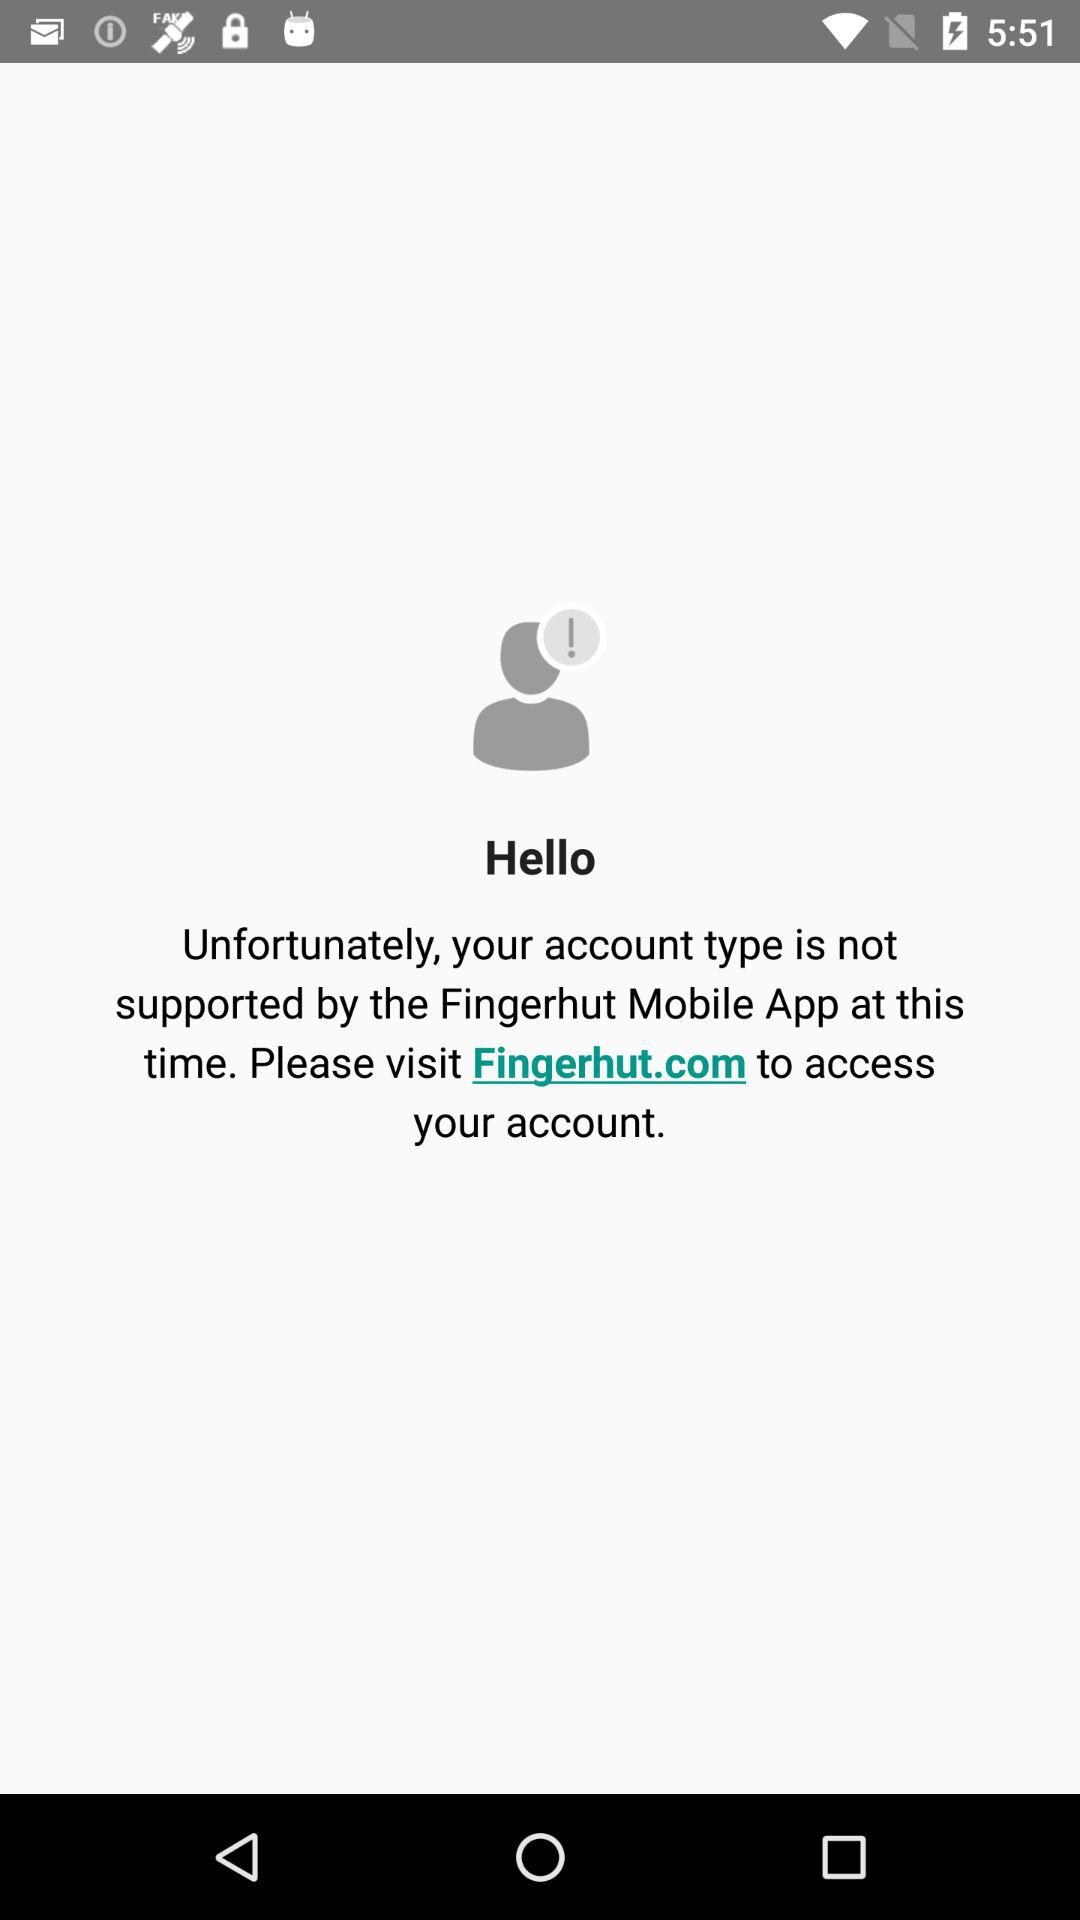Which version of the application is this?
When the provided information is insufficient, respond with <no answer>. <no answer> 